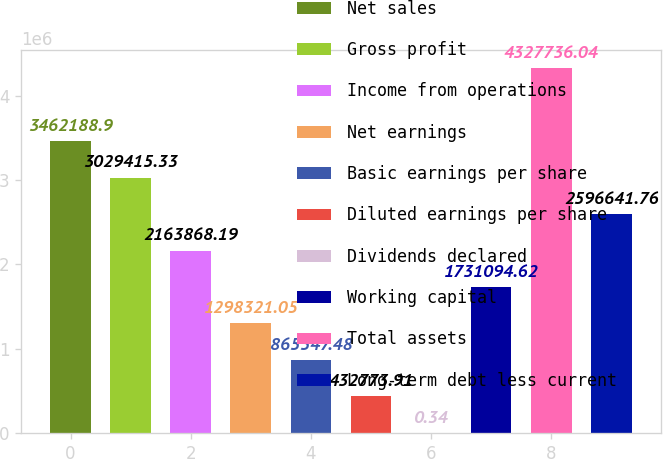Convert chart to OTSL. <chart><loc_0><loc_0><loc_500><loc_500><bar_chart><fcel>Net sales<fcel>Gross profit<fcel>Income from operations<fcel>Net earnings<fcel>Basic earnings per share<fcel>Diluted earnings per share<fcel>Dividends declared<fcel>Working capital<fcel>Total assets<fcel>Long-term debt less current<nl><fcel>3.46219e+06<fcel>3.02942e+06<fcel>2.16387e+06<fcel>1.29832e+06<fcel>865547<fcel>432774<fcel>0.34<fcel>1.73109e+06<fcel>4.32774e+06<fcel>2.59664e+06<nl></chart> 